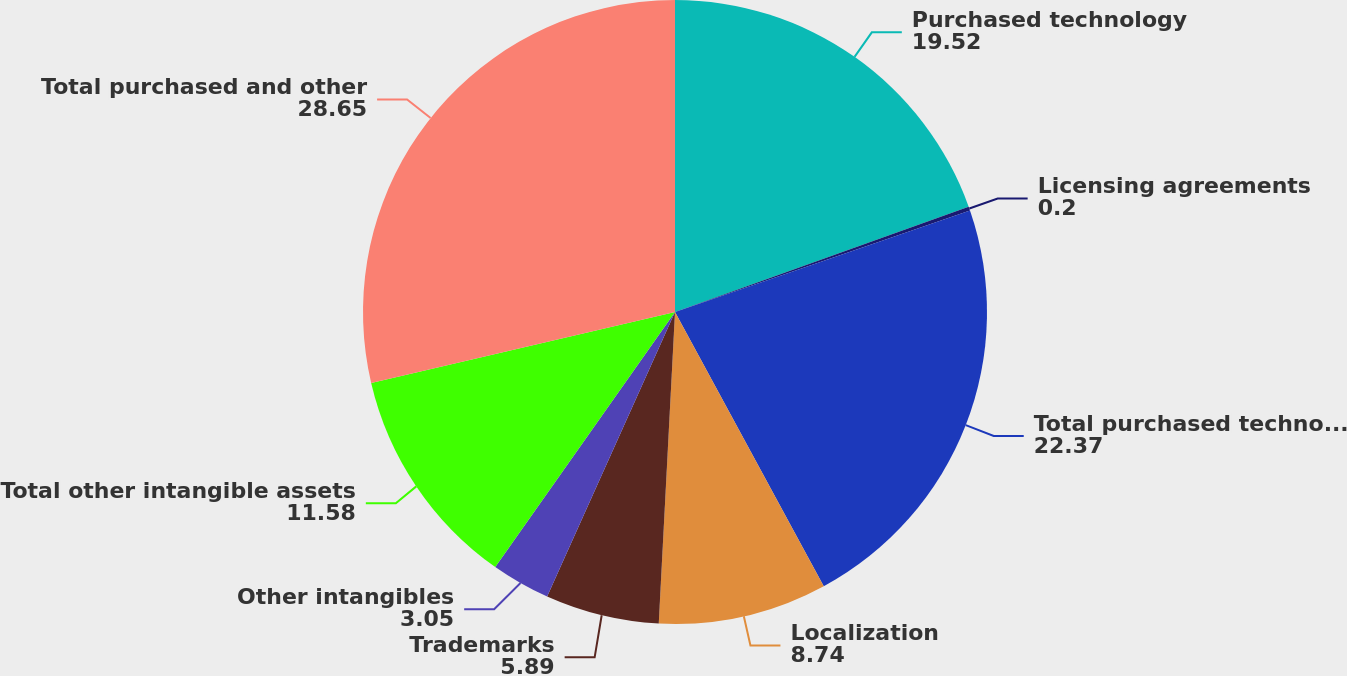Convert chart to OTSL. <chart><loc_0><loc_0><loc_500><loc_500><pie_chart><fcel>Purchased technology<fcel>Licensing agreements<fcel>Total purchased technology and<fcel>Localization<fcel>Trademarks<fcel>Other intangibles<fcel>Total other intangible assets<fcel>Total purchased and other<nl><fcel>19.52%<fcel>0.2%<fcel>22.37%<fcel>8.74%<fcel>5.89%<fcel>3.05%<fcel>11.58%<fcel>28.65%<nl></chart> 